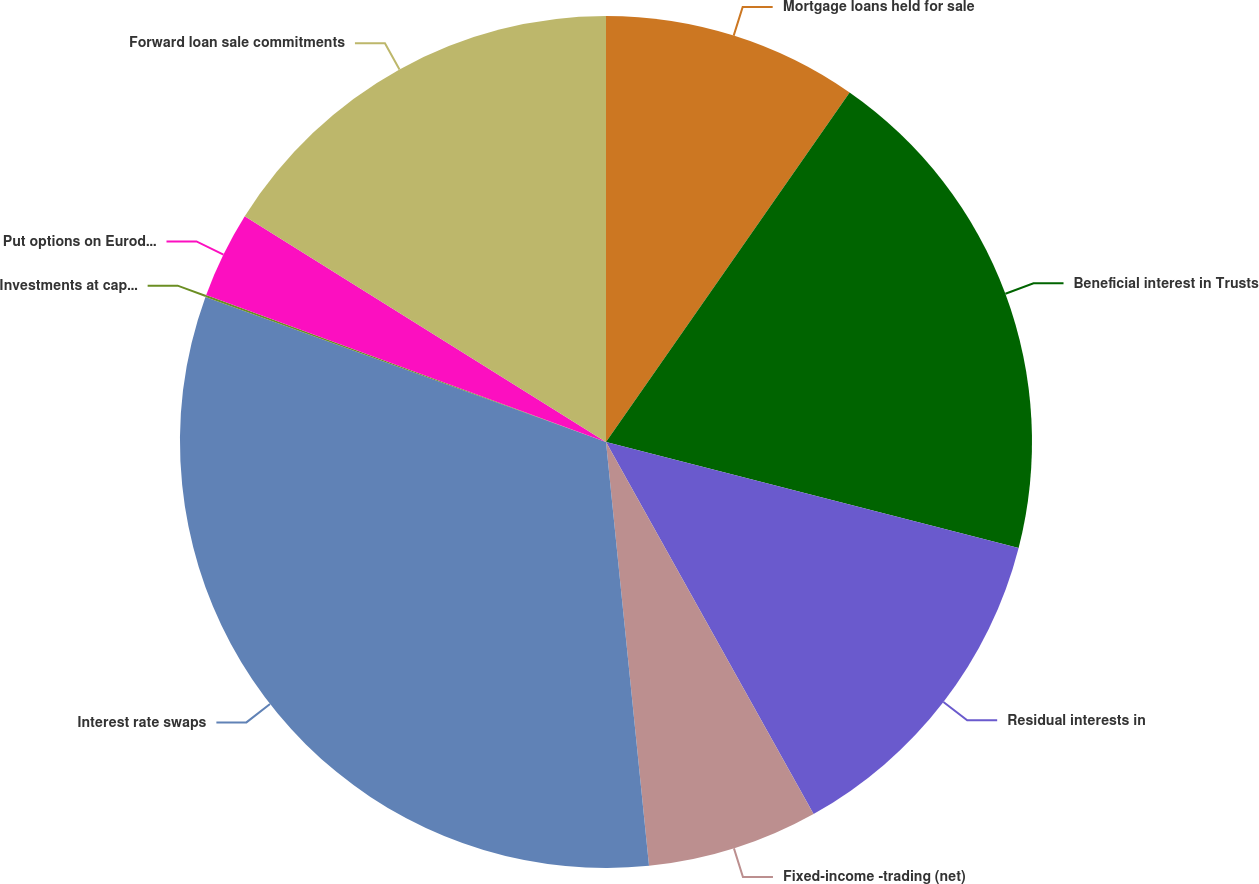Convert chart to OTSL. <chart><loc_0><loc_0><loc_500><loc_500><pie_chart><fcel>Mortgage loans held for sale<fcel>Beneficial interest in Trusts<fcel>Residual interests in<fcel>Fixed-income -trading (net)<fcel>Interest rate swaps<fcel>Investments at captive<fcel>Put options on Eurodollar<fcel>Forward loan sale commitments<nl><fcel>9.69%<fcel>19.31%<fcel>12.9%<fcel>6.49%<fcel>32.14%<fcel>0.08%<fcel>3.28%<fcel>16.11%<nl></chart> 